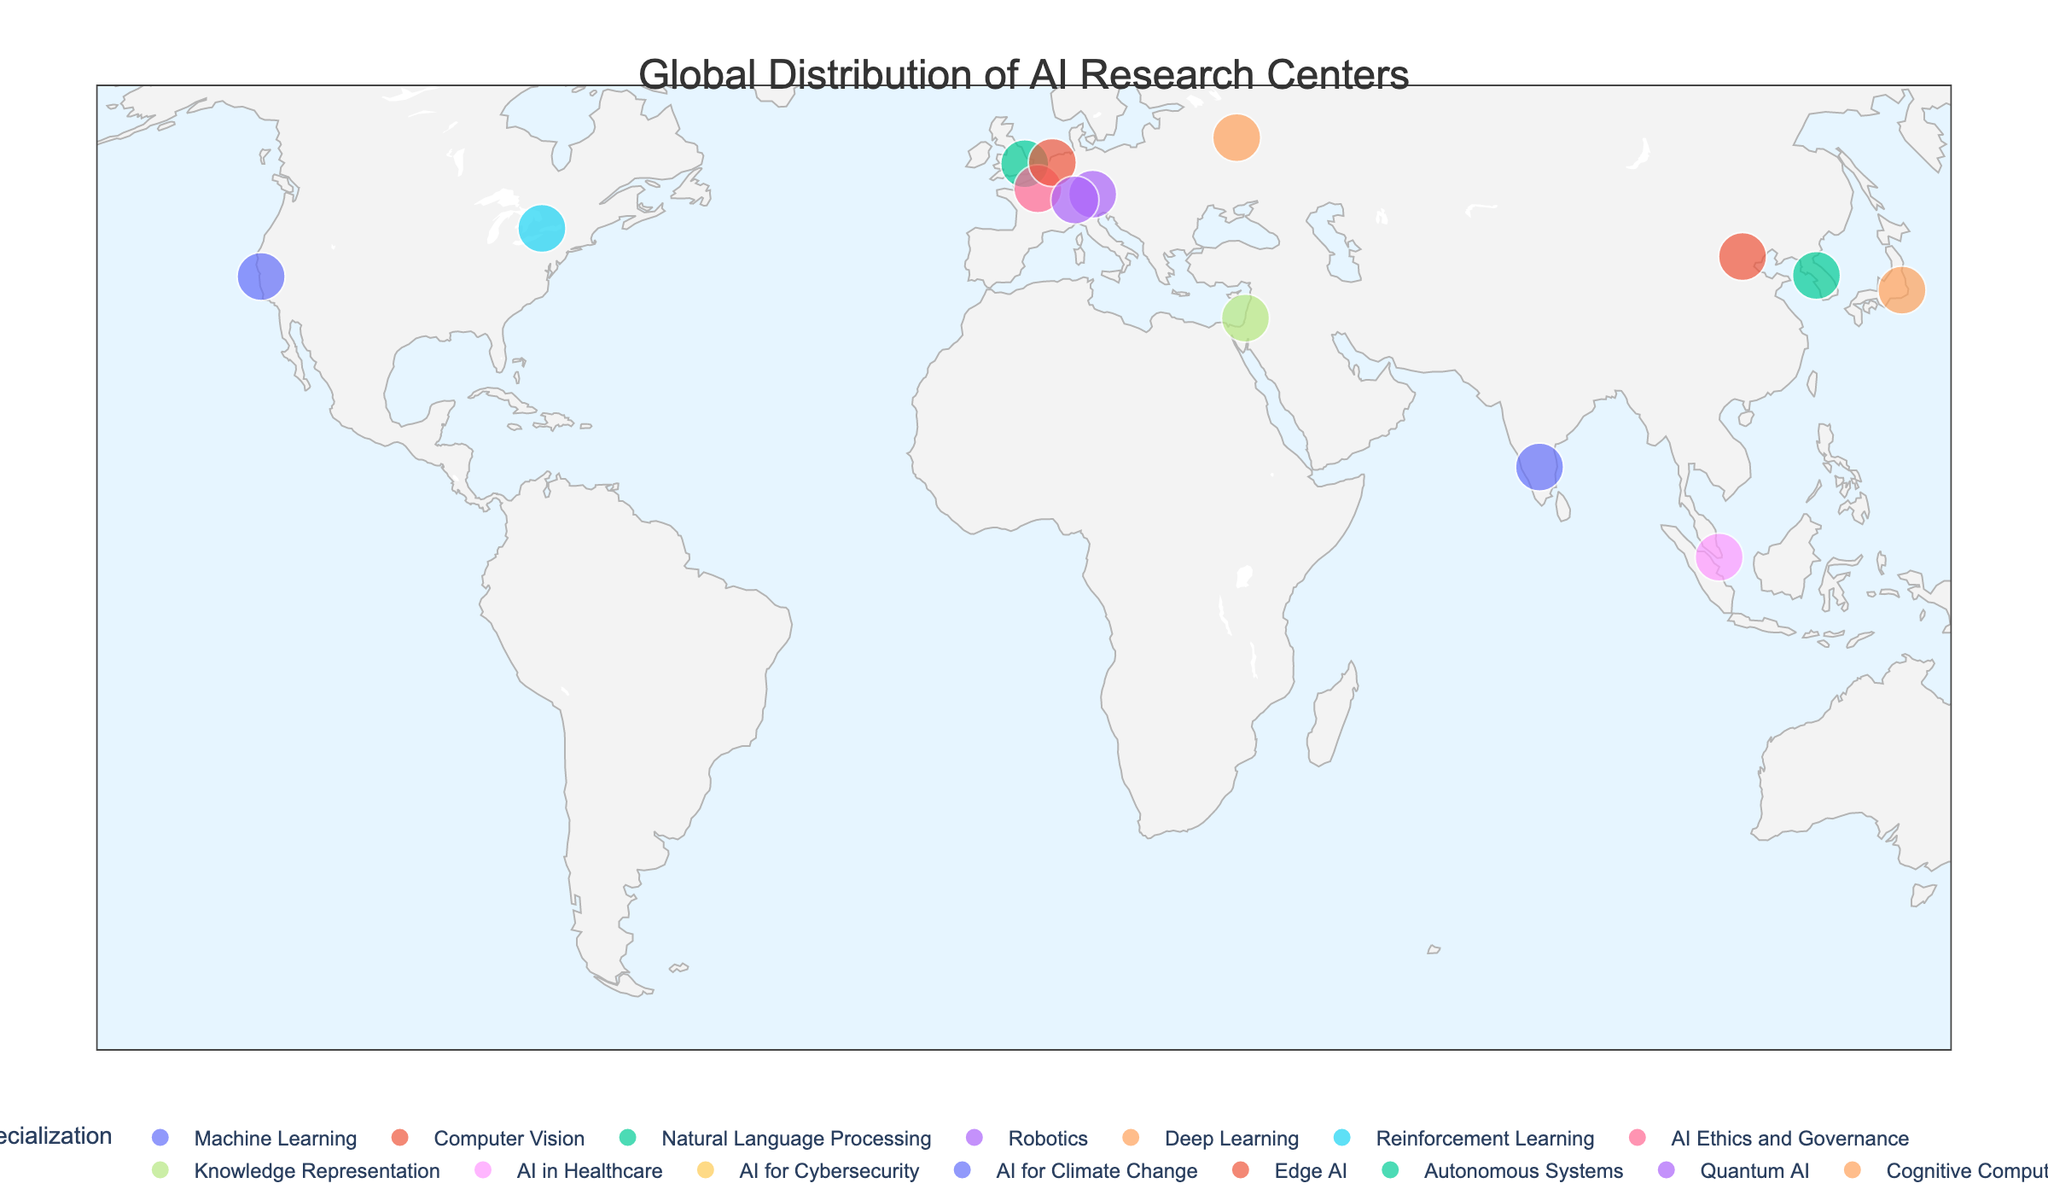What's the title of the geographical plot? The title of the geographical plot is usually written prominently at the top of the figure. In this case, the title is shown as "Global Distribution of AI Research Centers".
Answer: Global Distribution of AI Research Centers How many AI research centers are depicted in the plot? By counting the number of data points or markers on the map, we can determine the number of AI research centers depicted. The size attribute used in the plot also makes the centers more prominent, facilitating counting.
Answer: 15 Which AI research center is located in Germany and what is its specialization? By hovering over the markers on Germany and reading the `Specialization` and `Research Center` information that appears, we find the AI research center in Germany.
Answer: Max Planck Institute for Intelligent Systems, Robotics What is the latitude and longitude of the AI research center specializing in Quantum AI? Located by identifying the specialization "Quantum AI" on the map, we then check the latitudinal and longitudinal points associated with it. In this plot, it is in Zurich, Switzerland.
Answer: 47.3769, 8.5417 Which country has the most diverse AI specializations listed? We analyze the countries and count the number of different specializations listed next to their AI research centers. Multiple centers in the same country with different specializations would indicate diversity. By reviewing visually, it's evident that each country in the plot is shown with one specialization, making them equally diverse.
Answer: All listed countries have one specialization each Compare the number of AI research centers in North America to those in Asia. Which continent has more? By visually identifying and counting the centers located in North America (e.g., USA, Canada) and contrasting those with the centers in Asia (e.g., China, Japan, South Korea, Singapore, Israel), we determine that North America has fewer centers compared to Asia. We then sum each count to see which is higher.
Answer: Asia has more What is the predominant specialization in AI research centers based on the map? Analyzing the colors or markers associated with the specializations and checking which specialization appears most frequently in the plot helps identify the predominant one. Since each specialization appears only once, there is no single predominant specialization.
Answer: None (Even distribution) Where is the AI research center focusing on AI for Cybersecurity located? By hovering over the markers and looking for the specialization "AI for Cybersecurity", we can find the geographical location pinpointed in Sydney, Australia.
Answer: Sydney, Australia Which AI research center is positioned the farthest south on the map? Visually checking the latitude values of each center's markers, the one with the most negative value (towards the south) will be the farthest south. By inspection, the center in Sydney, Australia, is the farthest south.
Answer: CSIRO's Data61 How many AI research centers in the plot focus specifically on applications (e.g., AI in Healthcare, AI for Cybersecurity, AI for Climate Change)? By checking the specializations listed under applications and counting them, we identify three centers with application-specific focuses: AI in Healthcare, AI for Cybersecurity, and AI for Climate Change.
Answer: 3 